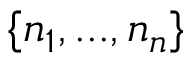<formula> <loc_0><loc_0><loc_500><loc_500>\{ n _ { 1 } , \dots , n _ { n } \}</formula> 